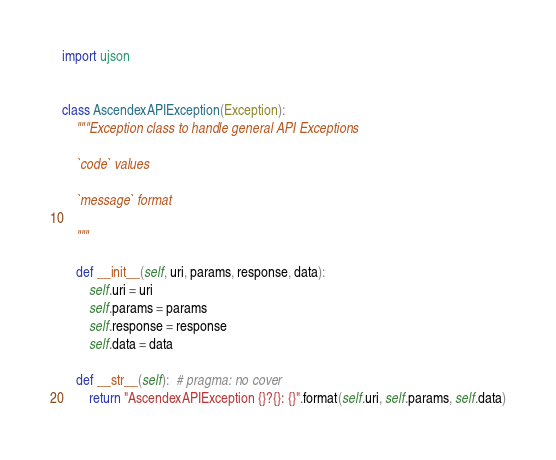Convert code to text. <code><loc_0><loc_0><loc_500><loc_500><_Python_>import ujson


class AscendexAPIException(Exception):
    """Exception class to handle general API Exceptions

    `code` values

    `message` format

    """

    def __init__(self, uri, params, response, data):
        self.uri = uri
        self.params = params
        self.response = response
        self.data = data

    def __str__(self):  # pragma: no cover
        return "AscendexAPIException {}?{}: {}".format(self.uri, self.params, self.data)
</code> 